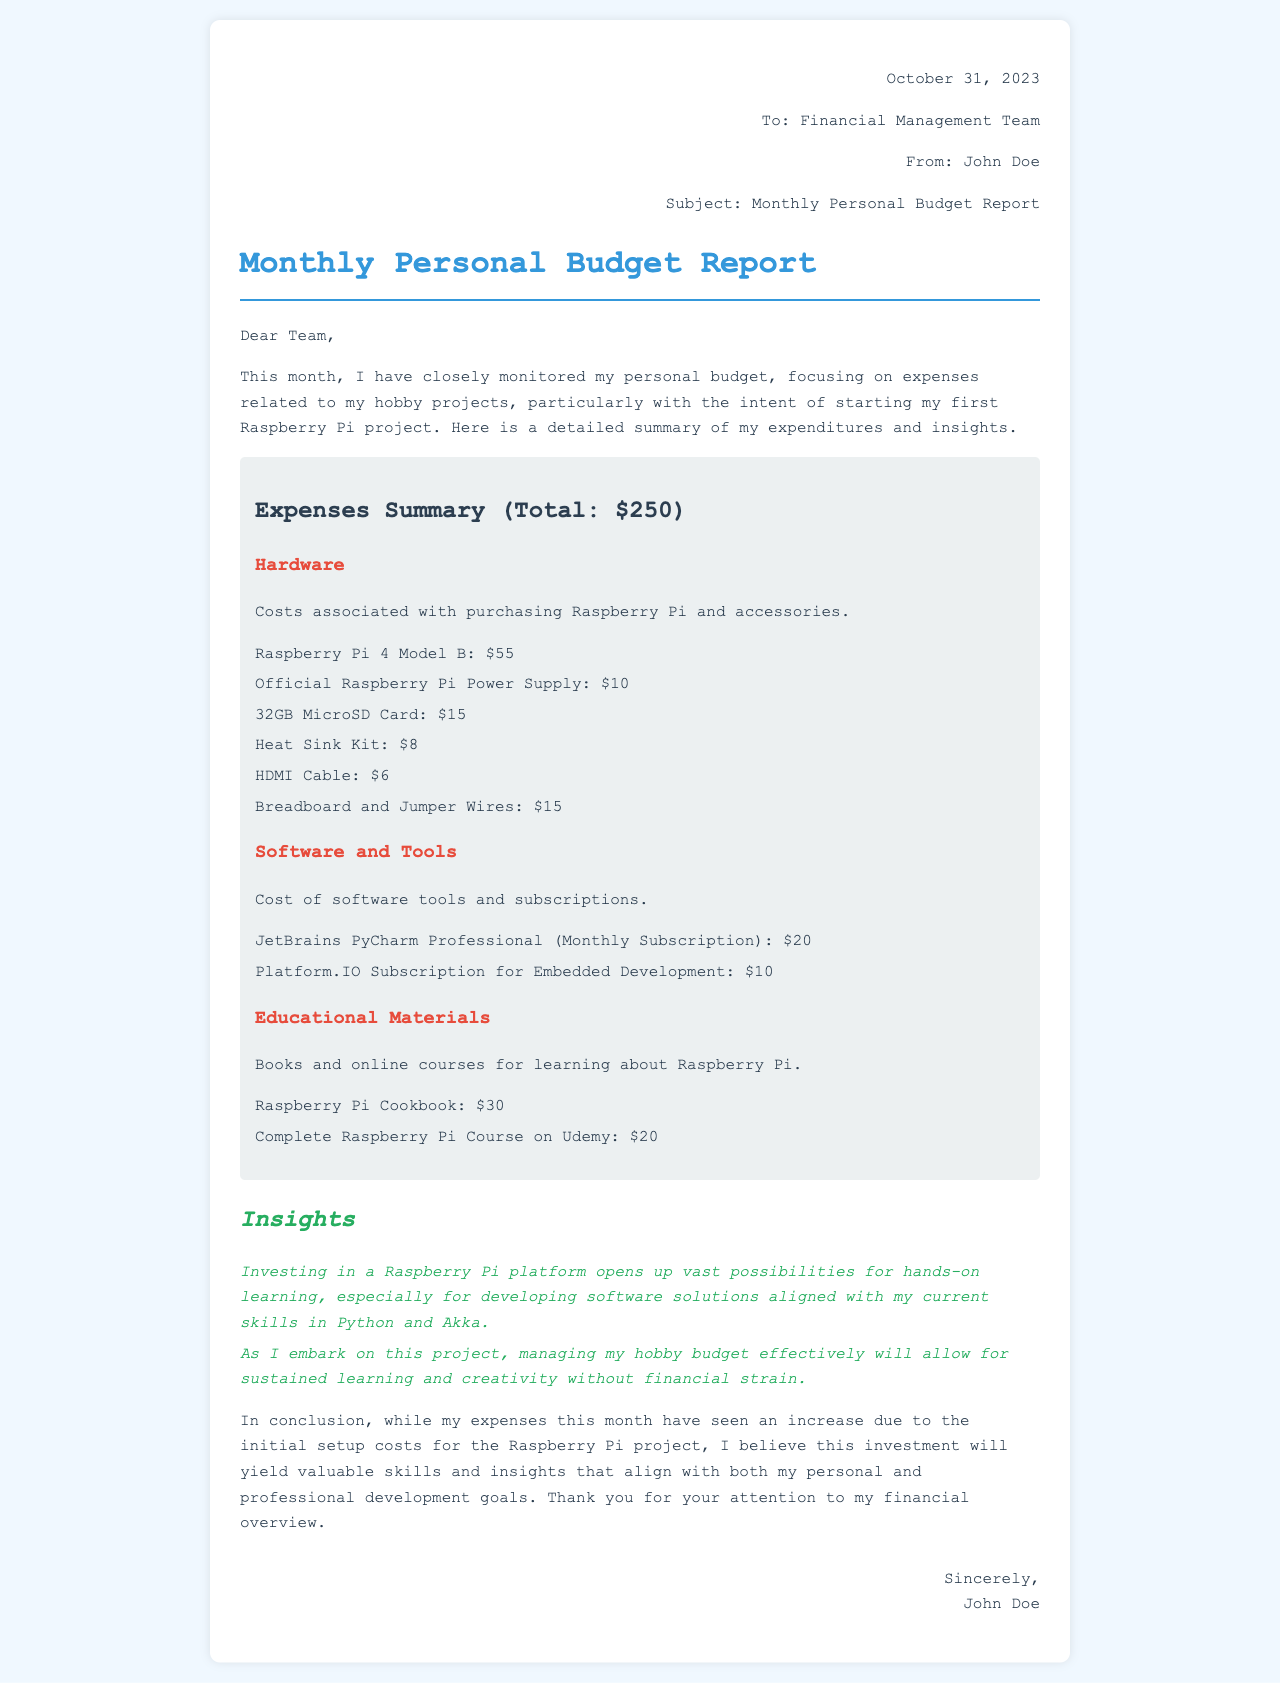what is the total amount of expenses reported? The total amount of expenses is indicated at the beginning of the expenses summary section.
Answer: $250 how much did the Raspberry Pi 4 Model B cost? The cost of the Raspberry Pi 4 Model B is listed under the hardware expenses.
Answer: $55 which educational material was purchased for $30? The document notes that the Raspberry Pi Cookbook was bought for this amount.
Answer: Raspberry Pi Cookbook what is the cost of the JetBrains PyCharm Professional subscription? The document specifies that the monthly subscription for JetBrains PyCharm Professional is mentioned under software and tools.
Answer: $20 which expense category includes breadboard and jumper wires? The expense category that features these items is identified in the hardware section of the report.
Answer: Hardware how many items were listed under the software and tools category? By counting the items mentioned, the number of software and tools listed can be obtained from that category.
Answer: 2 what insights does the author mention about investing in Raspberry Pi? The author reflects on the potential benefits of investing in this platform towards hands-on learning and skill development.
Answer: Vast possibilities for hands-on learning who is the sender of the report? The sender of the budget report is mentioned at the end of the document.
Answer: John Doe when was the report dated? The date of the report is specified at the top of the document.
Answer: October 31, 2023 